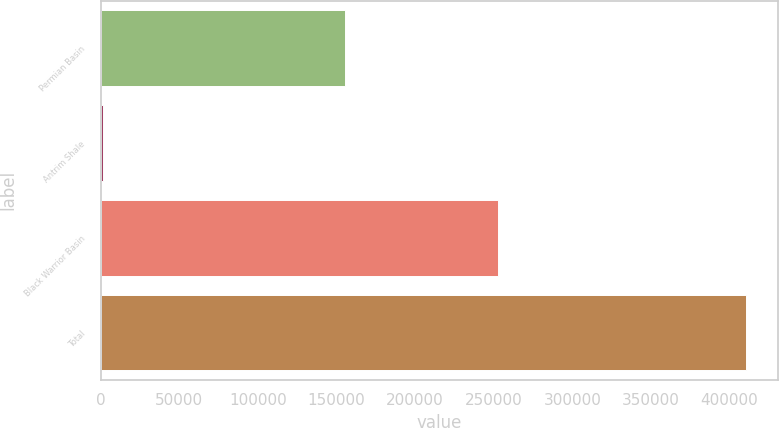<chart> <loc_0><loc_0><loc_500><loc_500><bar_chart><fcel>Permian Basin<fcel>Antrim Shale<fcel>Black Warrior Basin<fcel>Total<nl><fcel>155630<fcel>1778<fcel>252868<fcel>410276<nl></chart> 